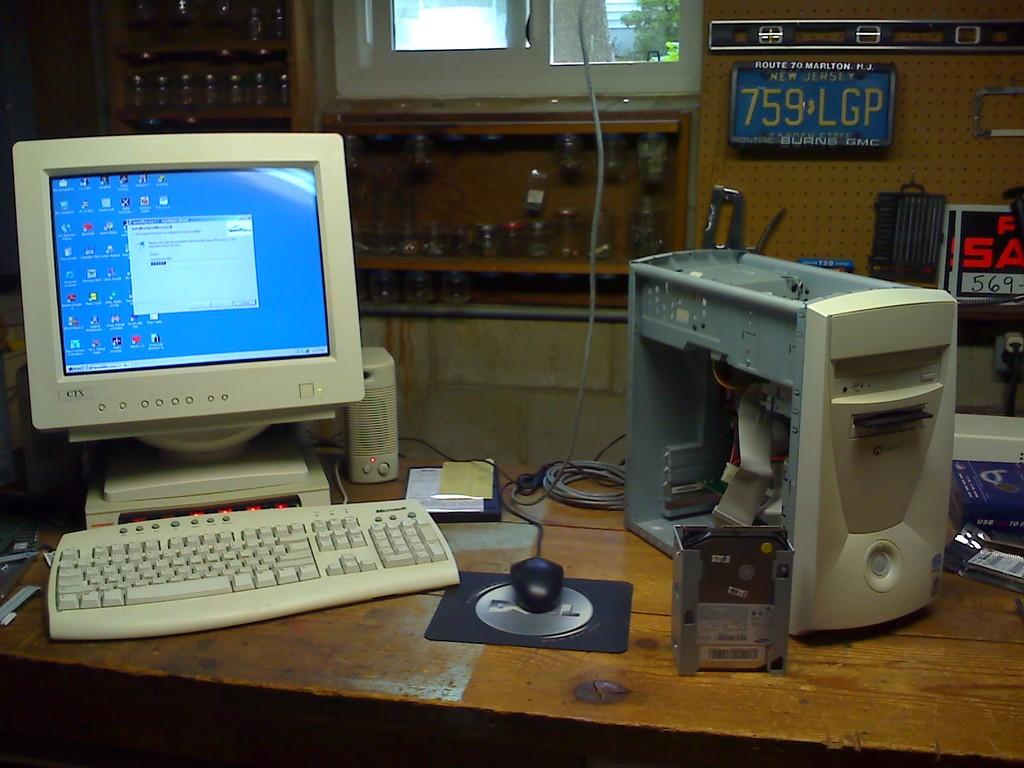What is the licenses plate in the background?
Offer a very short reply. 759 lgp. What is the number of the license plate on the wall?
Keep it short and to the point. 759 lgp. 